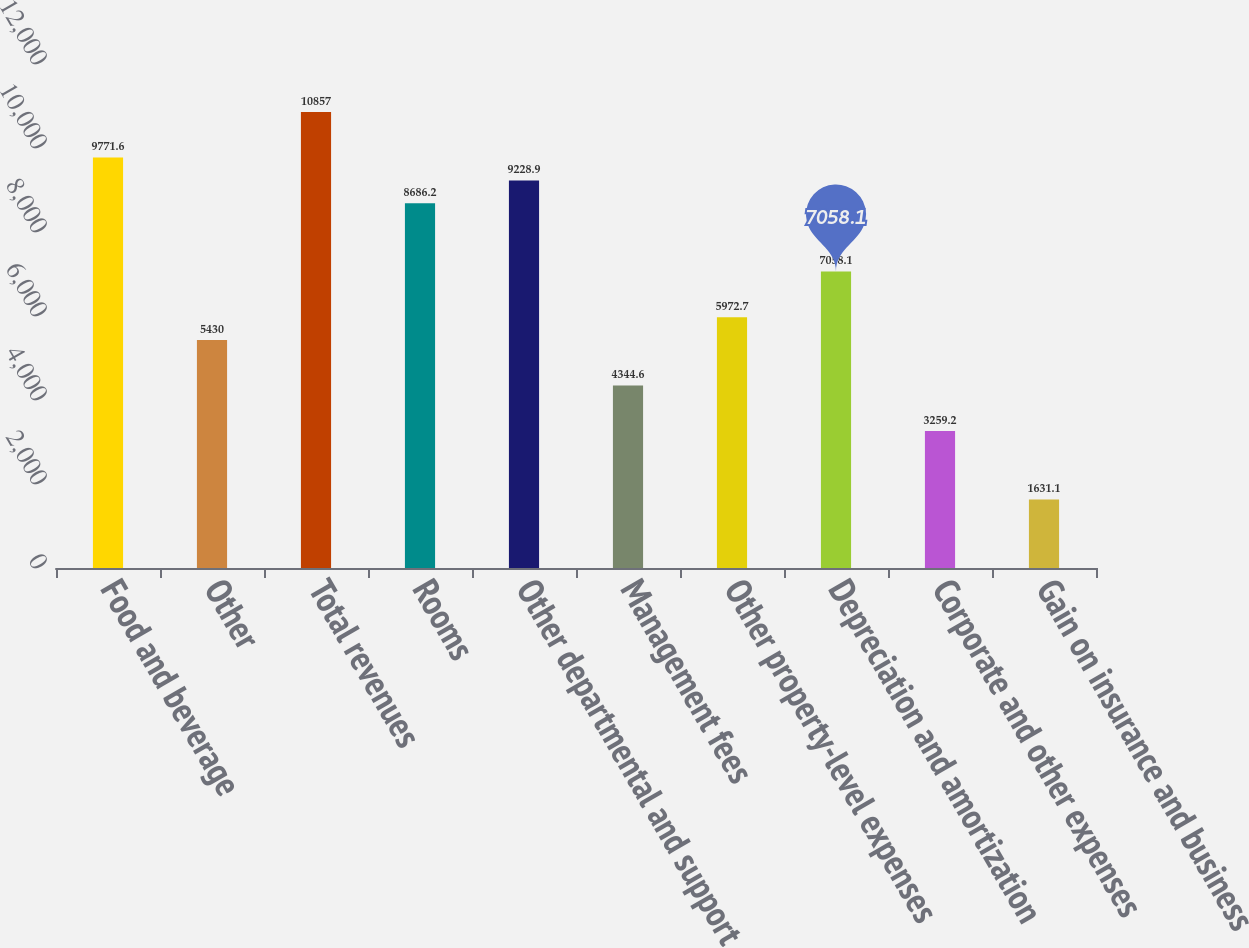Convert chart to OTSL. <chart><loc_0><loc_0><loc_500><loc_500><bar_chart><fcel>Food and beverage<fcel>Other<fcel>Total revenues<fcel>Rooms<fcel>Other departmental and support<fcel>Management fees<fcel>Other property-level expenses<fcel>Depreciation and amortization<fcel>Corporate and other expenses<fcel>Gain on insurance and business<nl><fcel>9771.6<fcel>5430<fcel>10857<fcel>8686.2<fcel>9228.9<fcel>4344.6<fcel>5972.7<fcel>7058.1<fcel>3259.2<fcel>1631.1<nl></chart> 